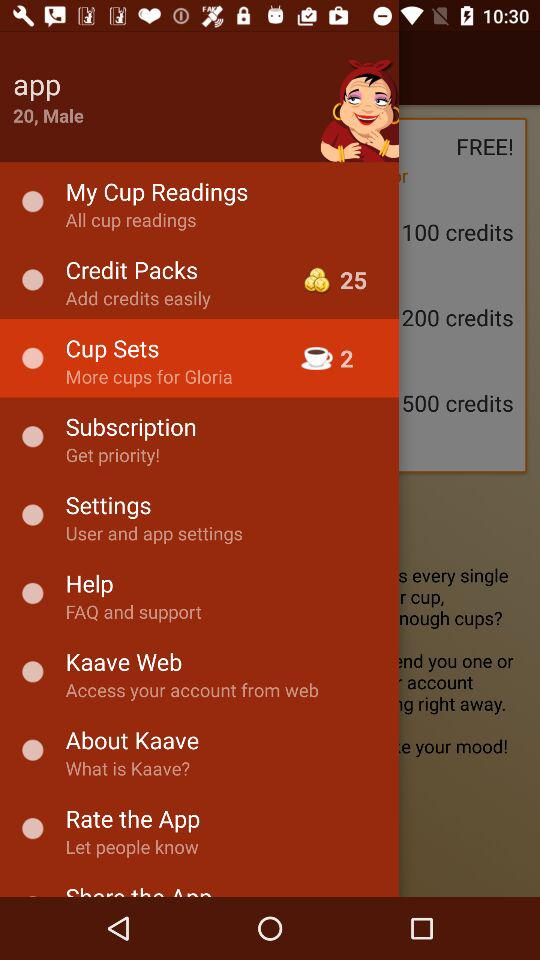What is the mentioned gender? The gender is male. 